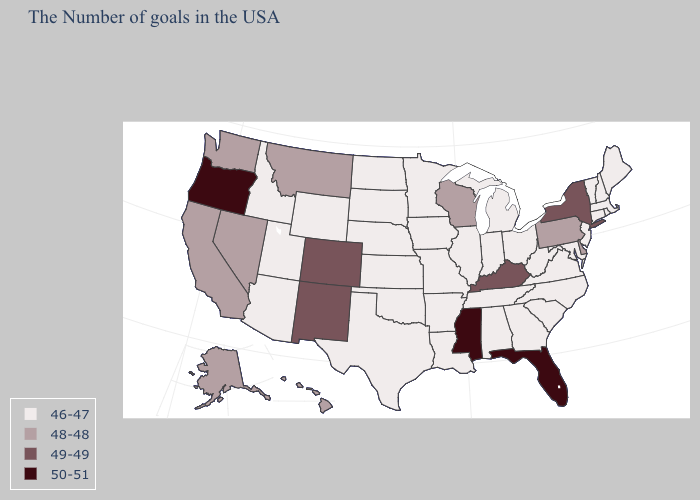Which states have the lowest value in the MidWest?
Keep it brief. Ohio, Michigan, Indiana, Illinois, Missouri, Minnesota, Iowa, Kansas, Nebraska, South Dakota, North Dakota. Name the states that have a value in the range 48-48?
Keep it brief. Delaware, Pennsylvania, Wisconsin, Montana, Nevada, California, Washington, Alaska, Hawaii. Which states have the lowest value in the West?
Concise answer only. Wyoming, Utah, Arizona, Idaho. Which states have the lowest value in the USA?
Quick response, please. Maine, Massachusetts, Rhode Island, New Hampshire, Vermont, Connecticut, New Jersey, Maryland, Virginia, North Carolina, South Carolina, West Virginia, Ohio, Georgia, Michigan, Indiana, Alabama, Tennessee, Illinois, Louisiana, Missouri, Arkansas, Minnesota, Iowa, Kansas, Nebraska, Oklahoma, Texas, South Dakota, North Dakota, Wyoming, Utah, Arizona, Idaho. Which states hav the highest value in the Northeast?
Answer briefly. New York. Among the states that border Maine , which have the highest value?
Give a very brief answer. New Hampshire. How many symbols are there in the legend?
Write a very short answer. 4. What is the highest value in the USA?
Write a very short answer. 50-51. Among the states that border Arizona , does New Mexico have the highest value?
Concise answer only. Yes. Is the legend a continuous bar?
Keep it brief. No. What is the lowest value in the West?
Concise answer only. 46-47. What is the value of Virginia?
Concise answer only. 46-47. Name the states that have a value in the range 46-47?
Give a very brief answer. Maine, Massachusetts, Rhode Island, New Hampshire, Vermont, Connecticut, New Jersey, Maryland, Virginia, North Carolina, South Carolina, West Virginia, Ohio, Georgia, Michigan, Indiana, Alabama, Tennessee, Illinois, Louisiana, Missouri, Arkansas, Minnesota, Iowa, Kansas, Nebraska, Oklahoma, Texas, South Dakota, North Dakota, Wyoming, Utah, Arizona, Idaho. Does Illinois have the same value as Delaware?
Be succinct. No. Among the states that border New Hampshire , which have the highest value?
Short answer required. Maine, Massachusetts, Vermont. 